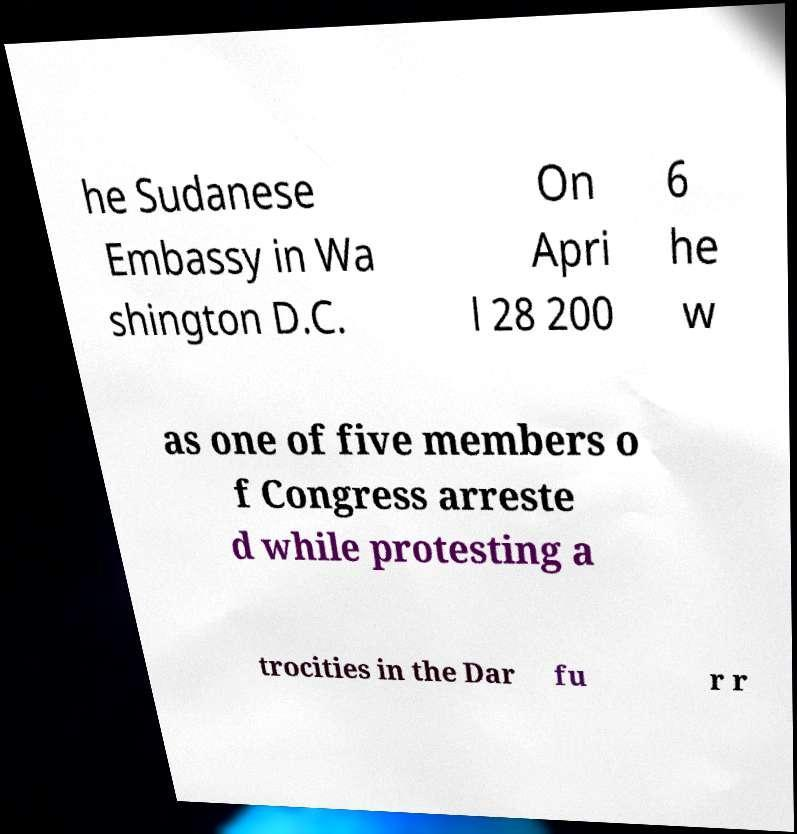Could you extract and type out the text from this image? he Sudanese Embassy in Wa shington D.C. On Apri l 28 200 6 he w as one of five members o f Congress arreste d while protesting a trocities in the Dar fu r r 